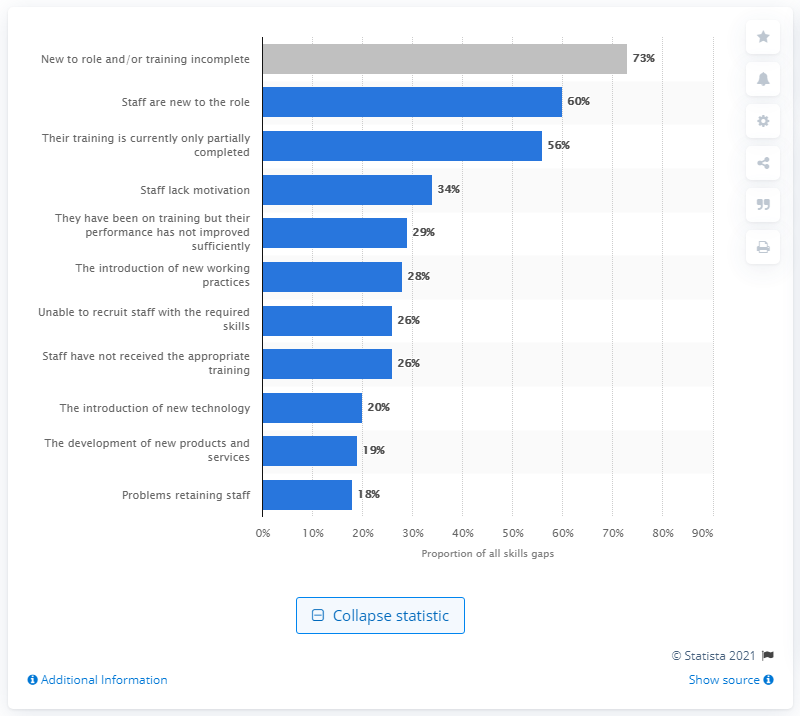Indicate a few pertinent items in this graphic. According to the report, 34% of employers reported a lack of motivation among their employees. 